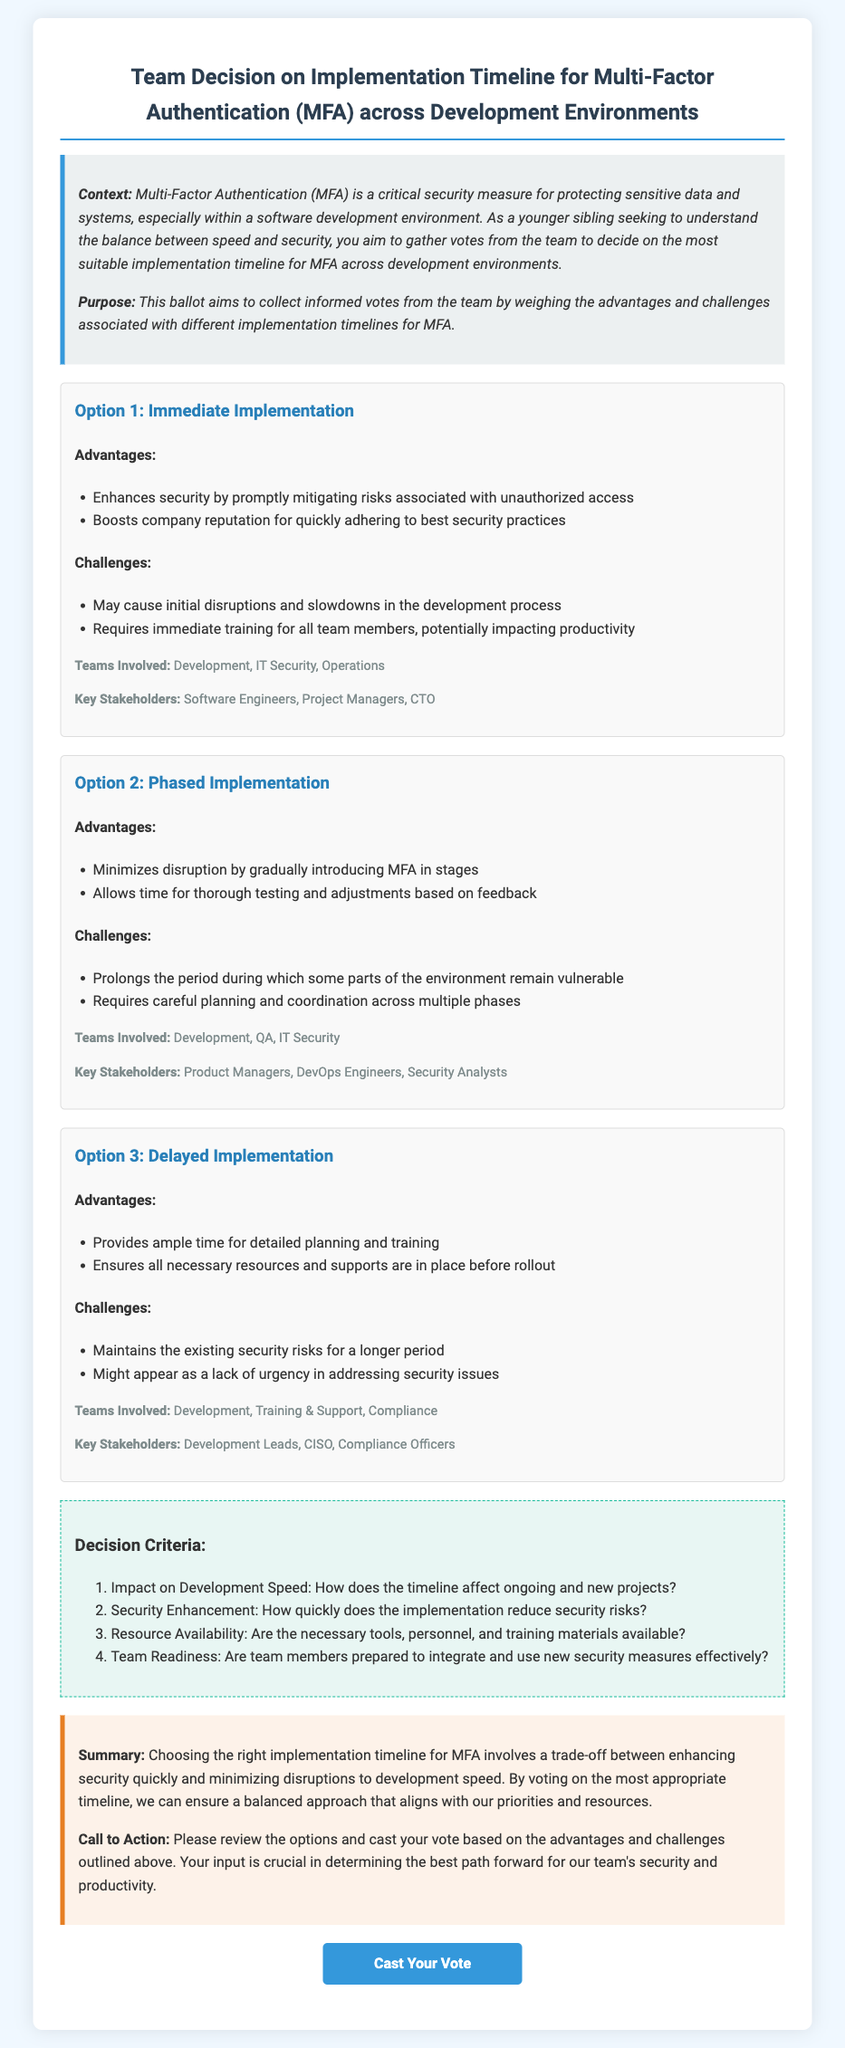What is the title of the document? The title of the document is indicated in the header section, which reads "Team Decision on Implementation Timeline for Multi-Factor Authentication (MFA) across Development Environments."
Answer: Team Decision on Implementation Timeline for Multi-Factor Authentication (MFA) across Development Environments What is the purpose of the ballot? The purpose of the ballot is stated in the introductory section, which clarifies that it aims to collect informed votes from the team about the implementation timelines for MFA.
Answer: To collect informed votes from the team What are the advantages of Immediate Implementation? The advantages are listed under Option 1 and include specific security benefits and reputational boosts.
Answer: Enhances security, Boosts company reputation What is a challenge of Phased Implementation? The challenges mentioned for Phased Implementation under Option 2 note the prolonged vulnerability of certain environments.
Answer: Prolongs the period of vulnerability What are the teams involved in Delayed Implementation? The document lists the teams involved under Option 3, indicating who plays a role in this implementation strategy.
Answer: Development, Training & Support, Compliance How many decision criteria are listed in the document? The number of decision criteria is mentioned in the section titled "Decision Criteria," where it lists a specific number.
Answer: Four Which option allows time for thorough testing and adjustments? The reasoning is based on the advantages listed for the respective implementation options.
Answer: Phased Implementation What is the call to action for voting? The call to action is summarized in the conclusion, directing readers on how to participate in the voting process.
Answer: Please review the options and cast your vote 